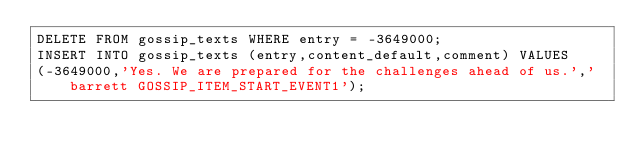Convert code to text. <code><loc_0><loc_0><loc_500><loc_500><_SQL_>DELETE FROM gossip_texts WHERE entry = -3649000;
INSERT INTO gossip_texts (entry,content_default,comment) VALUES
(-3649000,'Yes. We are prepared for the challenges ahead of us.','barrett GOSSIP_ITEM_START_EVENT1');
</code> 